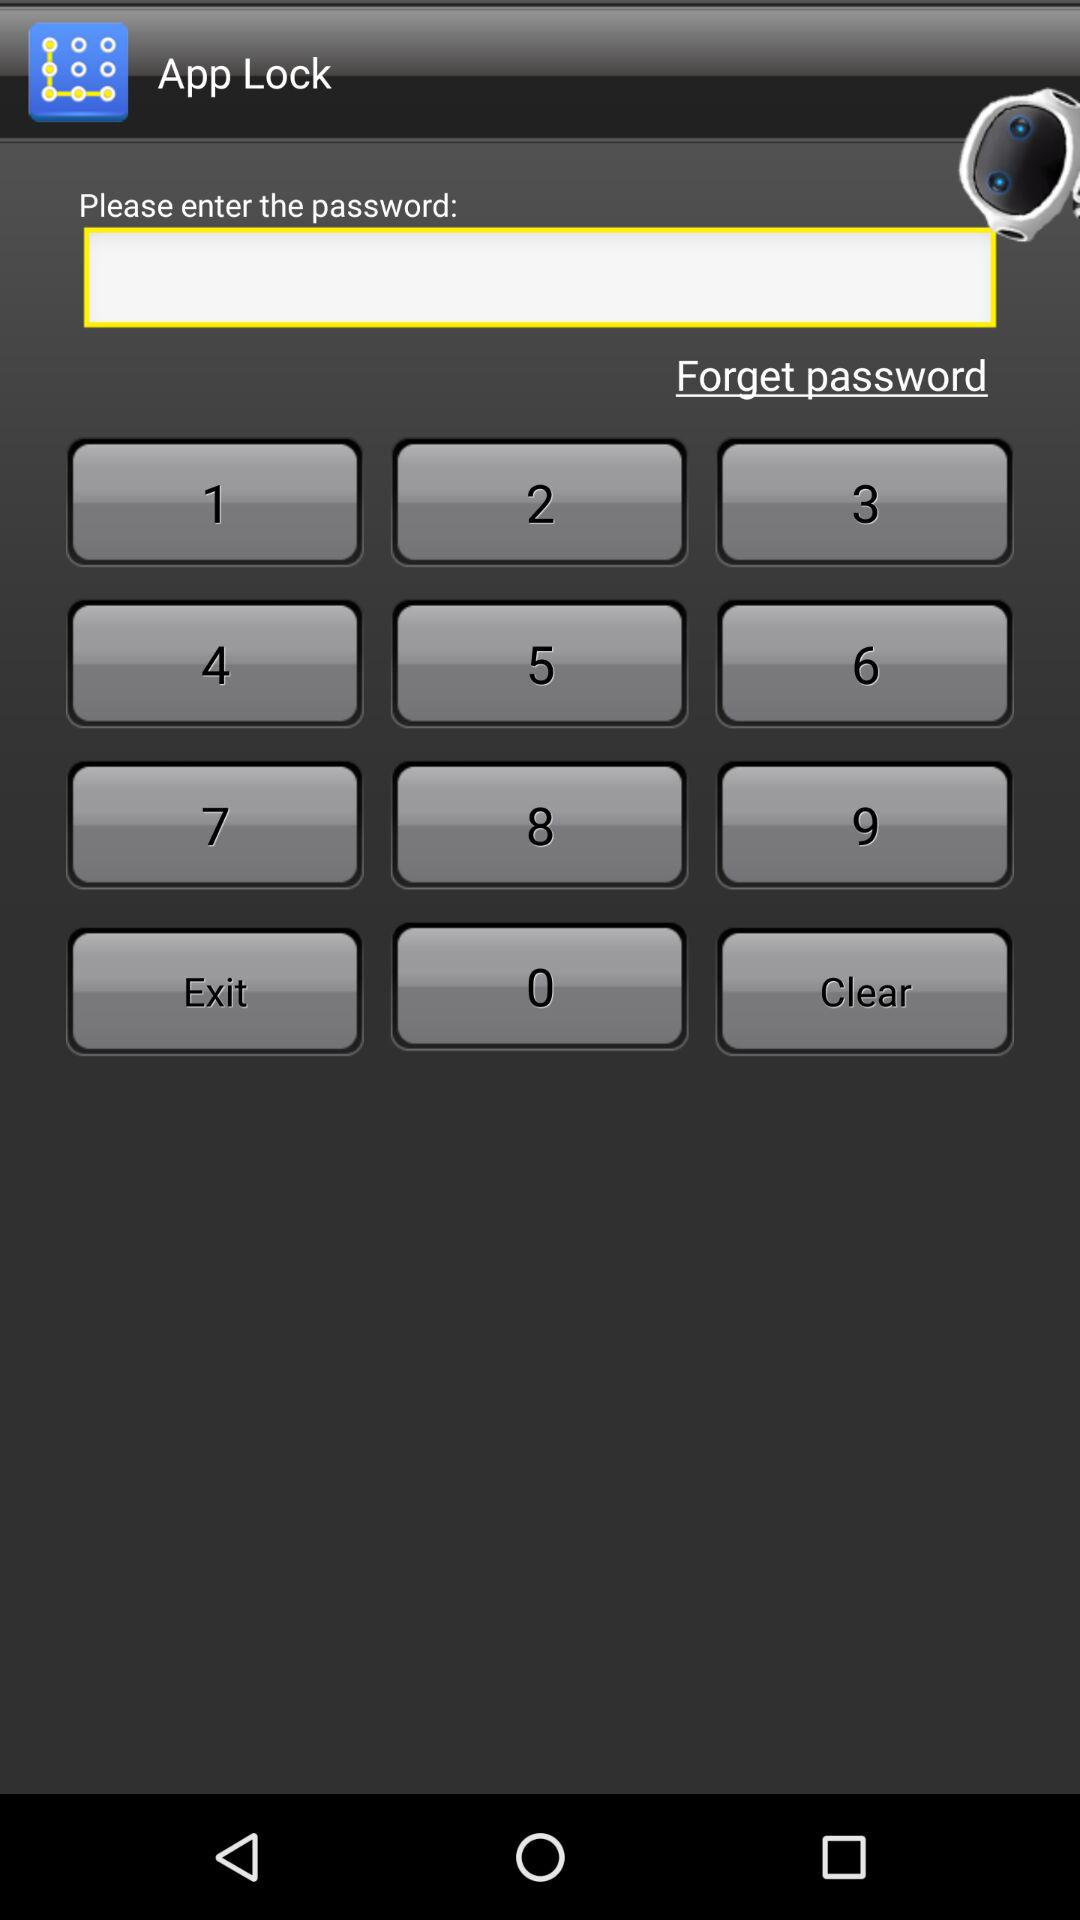What is the entered password?
When the provided information is insufficient, respond with <no answer>. <no answer> 